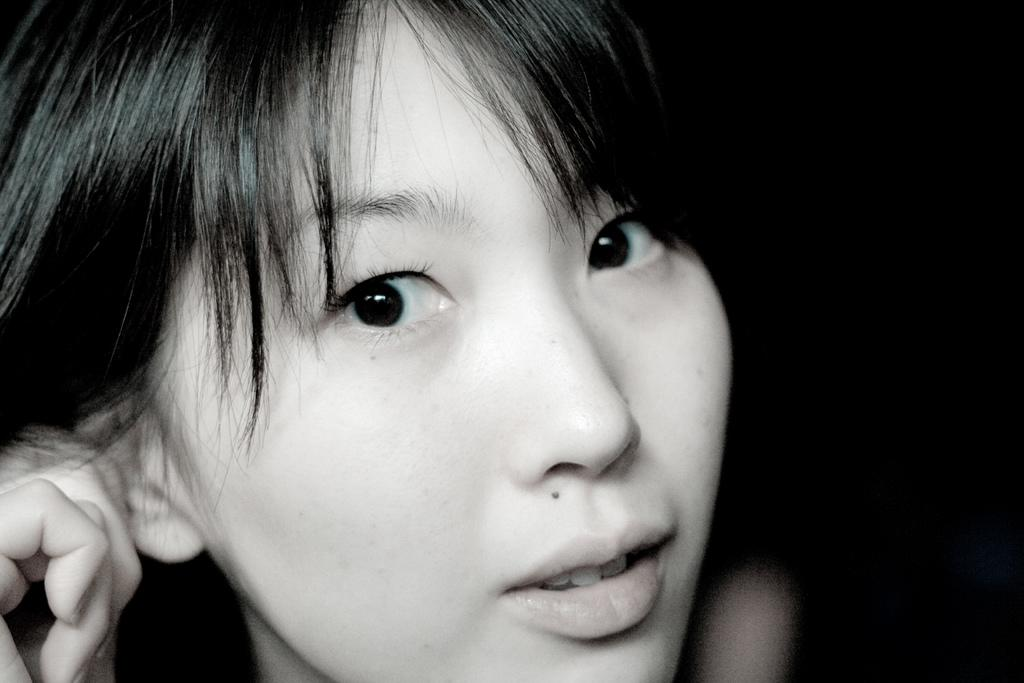What is the main subject of the image? There is a person in the image. What color scheme is used in the image? The image is in black and white. Can you see any cracks in the image? There are no cracks visible in the image, as it is a photograph of a person in black and white. Is there a kitty playing on a slope in the image? There is no kitty or slope present in the image; it features a person in black and white. 